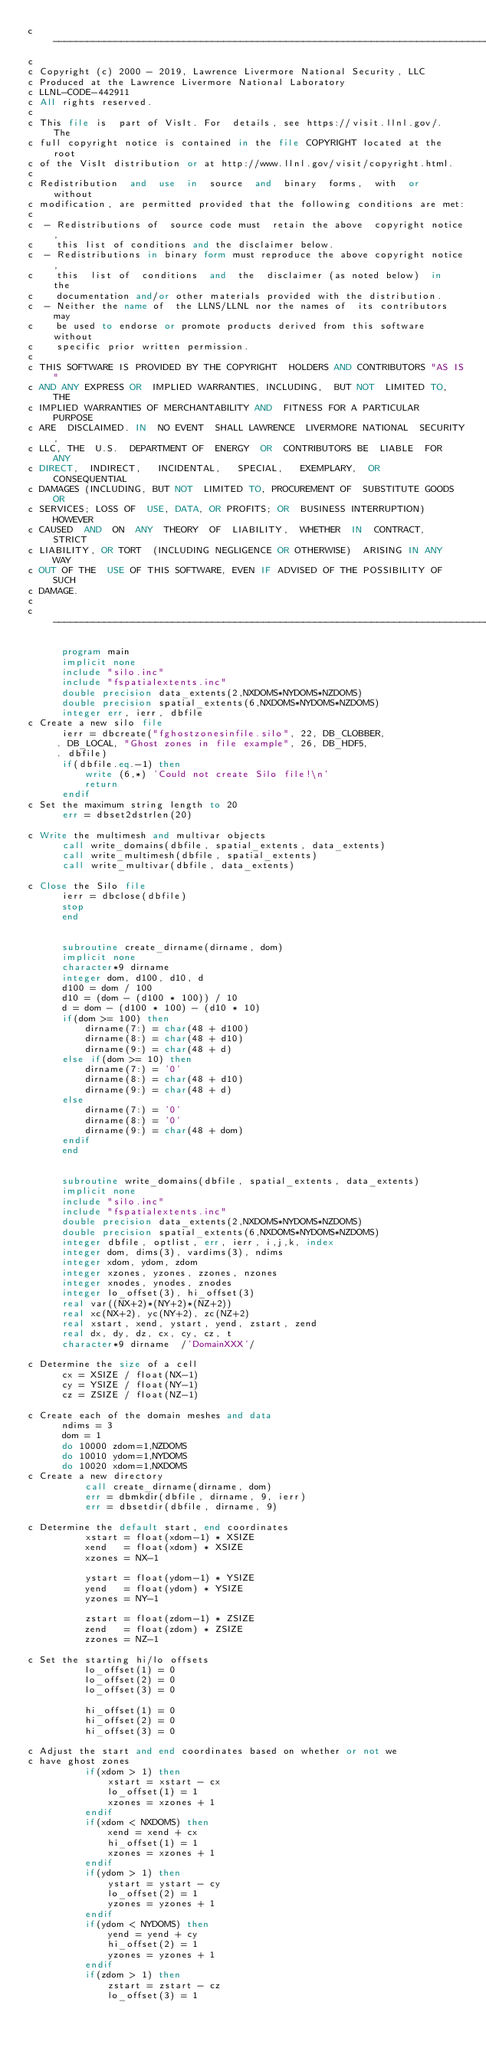Convert code to text. <code><loc_0><loc_0><loc_500><loc_500><_FORTRAN_>c-----------------------------------------------------------------------------
c
c Copyright (c) 2000 - 2019, Lawrence Livermore National Security, LLC
c Produced at the Lawrence Livermore National Laboratory
c LLNL-CODE-442911
c All rights reserved.
c
c This file is  part of VisIt. For  details, see https://visit.llnl.gov/.  The
c full copyright notice is contained in the file COPYRIGHT located at the root
c of the VisIt distribution or at http://www.llnl.gov/visit/copyright.html.
c
c Redistribution  and  use  in  source  and  binary  forms,  with  or  without
c modification, are permitted provided that the following conditions are met:
c
c  - Redistributions of  source code must  retain the above  copyright notice,
c    this list of conditions and the disclaimer below.
c  - Redistributions in binary form must reproduce the above copyright notice,
c    this  list of  conditions  and  the  disclaimer (as noted below)  in  the
c    documentation and/or other materials provided with the distribution.
c  - Neither the name of  the LLNS/LLNL nor the names of  its contributors may
c    be used to endorse or promote products derived from this software without
c    specific prior written permission.
c
c THIS SOFTWARE IS PROVIDED BY THE COPYRIGHT  HOLDERS AND CONTRIBUTORS "AS IS"
c AND ANY EXPRESS OR  IMPLIED WARRANTIES, INCLUDING,  BUT NOT  LIMITED TO, THE
c IMPLIED WARRANTIES OF MERCHANTABILITY AND  FITNESS FOR A PARTICULAR  PURPOSE
c ARE  DISCLAIMED. IN  NO EVENT  SHALL LAWRENCE  LIVERMORE NATIONAL  SECURITY,
c LLC, THE  U.S.  DEPARTMENT OF  ENERGY  OR  CONTRIBUTORS BE  LIABLE  FOR  ANY
c DIRECT,  INDIRECT,   INCIDENTAL,   SPECIAL,   EXEMPLARY,  OR   CONSEQUENTIAL
c DAMAGES (INCLUDING, BUT NOT  LIMITED TO, PROCUREMENT OF  SUBSTITUTE GOODS OR
c SERVICES; LOSS OF  USE, DATA, OR PROFITS; OR  BUSINESS INTERRUPTION) HOWEVER
c CAUSED  AND  ON  ANY  THEORY  OF  LIABILITY,  WHETHER  IN  CONTRACT,  STRICT
c LIABILITY, OR TORT  (INCLUDING NEGLIGENCE OR OTHERWISE)  ARISING IN ANY  WAY
c OUT OF THE  USE OF THIS SOFTWARE, EVEN IF ADVISED OF THE POSSIBILITY OF SUCH
c DAMAGE.
c
c-----------------------------------------------------------------------------

      program main
      implicit none
      include "silo.inc"
      include "fspatialextents.inc"
      double precision data_extents(2,NXDOMS*NYDOMS*NZDOMS)
      double precision spatial_extents(6,NXDOMS*NYDOMS*NZDOMS)
      integer err, ierr, dbfile
c Create a new silo file
      ierr = dbcreate("fghostzonesinfile.silo", 22, DB_CLOBBER,
     . DB_LOCAL, "Ghost zones in file example", 26, DB_HDF5,
     . dbfile)
      if(dbfile.eq.-1) then
          write (6,*) 'Could not create Silo file!\n'
          return
      endif
c Set the maximum string length to 20
      err = dbset2dstrlen(20)

c Write the multimesh and multivar objects
      call write_domains(dbfile, spatial_extents, data_extents)
      call write_multimesh(dbfile, spatial_extents)
      call write_multivar(dbfile, data_extents)

c Close the Silo file
      ierr = dbclose(dbfile)
      stop
      end


      subroutine create_dirname(dirname, dom)
      implicit none
      character*9 dirname
      integer dom, d100, d10, d
      d100 = dom / 100
      d10 = (dom - (d100 * 100)) / 10
      d = dom - (d100 * 100) - (d10 * 10)
      if(dom >= 100) then
          dirname(7:) = char(48 + d100)
          dirname(8:) = char(48 + d10)
          dirname(9:) = char(48 + d)
      else if(dom >= 10) then
          dirname(7:) = '0'
          dirname(8:) = char(48 + d10)
          dirname(9:) = char(48 + d)
      else
          dirname(7:) = '0'
          dirname(8:) = '0'
          dirname(9:) = char(48 + dom)
      endif
      end


      subroutine write_domains(dbfile, spatial_extents, data_extents)
      implicit none
      include "silo.inc"
      include "fspatialextents.inc"
      double precision data_extents(2,NXDOMS*NYDOMS*NZDOMS)
      double precision spatial_extents(6,NXDOMS*NYDOMS*NZDOMS)
      integer dbfile, optlist, err, ierr, i,j,k, index
      integer dom, dims(3), vardims(3), ndims
      integer xdom, ydom, zdom
      integer xzones, yzones, zzones, nzones
      integer xnodes, ynodes, znodes
      integer lo_offset(3), hi_offset(3)
      real var((NX+2)*(NY+2)*(NZ+2))
      real xc(NX+2), yc(NY+2), zc(NZ+2)
      real xstart, xend, ystart, yend, zstart, zend
      real dx, dy, dz, cx, cy, cz, t
      character*9 dirname  /'DomainXXX'/

c Determine the size of a cell
      cx = XSIZE / float(NX-1)
      cy = YSIZE / float(NY-1)
      cz = ZSIZE / float(NZ-1)

c Create each of the domain meshes and data
      ndims = 3
      dom = 1
      do 10000 zdom=1,NZDOMS
      do 10010 ydom=1,NYDOMS
      do 10020 xdom=1,NXDOMS
c Create a new directory
          call create_dirname(dirname, dom)
          err = dbmkdir(dbfile, dirname, 9, ierr)
          err = dbsetdir(dbfile, dirname, 9)

c Determine the default start, end coordinates
          xstart = float(xdom-1) * XSIZE
          xend   = float(xdom) * XSIZE
          xzones = NX-1

          ystart = float(ydom-1) * YSIZE
          yend   = float(ydom) * YSIZE
          yzones = NY-1

          zstart = float(zdom-1) * ZSIZE
          zend   = float(zdom) * ZSIZE
          zzones = NZ-1

c Set the starting hi/lo offsets
          lo_offset(1) = 0
          lo_offset(2) = 0
          lo_offset(3) = 0

          hi_offset(1) = 0
          hi_offset(2) = 0
          hi_offset(3) = 0

c Adjust the start and end coordinates based on whether or not we
c have ghost zones
          if(xdom > 1) then
              xstart = xstart - cx
              lo_offset(1) = 1
              xzones = xzones + 1
          endif
          if(xdom < NXDOMS) then
              xend = xend + cx
              hi_offset(1) = 1
              xzones = xzones + 1
          endif
          if(ydom > 1) then
              ystart = ystart - cy
              lo_offset(2) = 1
              yzones = yzones + 1
          endif
          if(ydom < NYDOMS) then
              yend = yend + cy
              hi_offset(2) = 1
              yzones = yzones + 1
          endif
          if(zdom > 1) then
              zstart = zstart - cz
              lo_offset(3) = 1</code> 